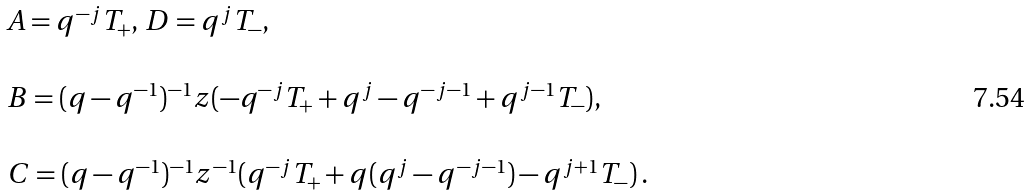Convert formula to latex. <formula><loc_0><loc_0><loc_500><loc_500>\begin{array} { l } A = q ^ { - j } T _ { + } , \, D = q ^ { j } T _ { - } , \\ \\ B = ( q - q ^ { - 1 } ) ^ { - 1 } z ( - q ^ { - j } T _ { + } + q ^ { j } - q ^ { - j - 1 } + q ^ { j - 1 } T _ { - } ) , \\ \\ C = ( q - q ^ { - 1 } ) ^ { - 1 } z ^ { - 1 } ( q ^ { - j } T _ { + } + q ( q ^ { j } - q ^ { - j - 1 } ) - q ^ { j + 1 } T _ { - } ) \, . \end{array}</formula> 